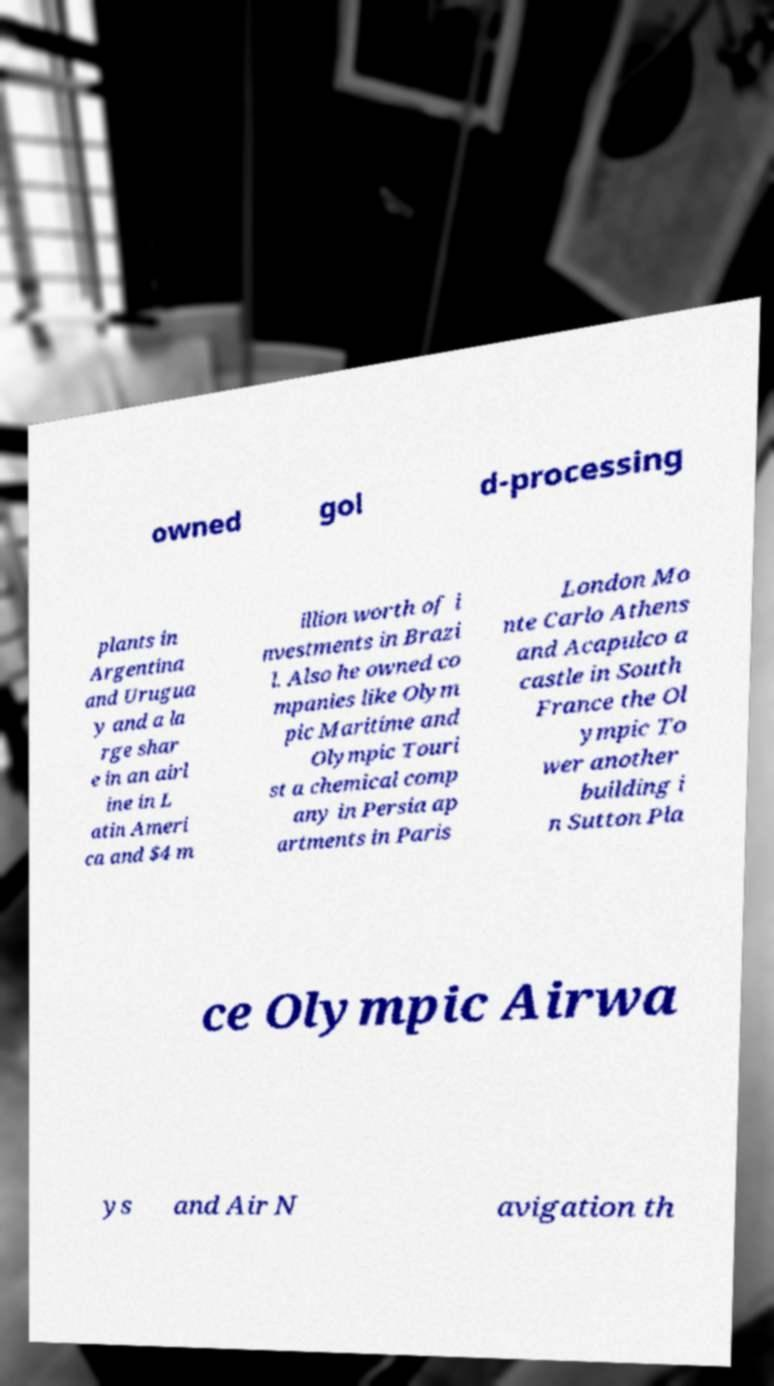Could you extract and type out the text from this image? owned gol d-processing plants in Argentina and Urugua y and a la rge shar e in an airl ine in L atin Ameri ca and $4 m illion worth of i nvestments in Brazi l. Also he owned co mpanies like Olym pic Maritime and Olympic Touri st a chemical comp any in Persia ap artments in Paris London Mo nte Carlo Athens and Acapulco a castle in South France the Ol ympic To wer another building i n Sutton Pla ce Olympic Airwa ys and Air N avigation th 